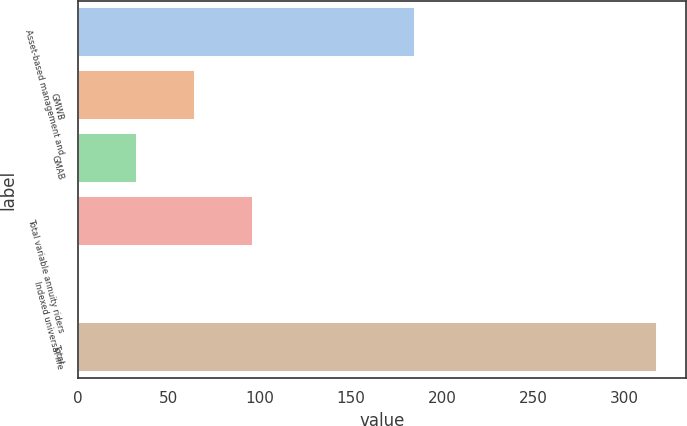<chart> <loc_0><loc_0><loc_500><loc_500><bar_chart><fcel>Asset-based management and<fcel>GMWB<fcel>GMAB<fcel>Total variable annuity riders<fcel>Indexed universal life<fcel>Total<nl><fcel>185<fcel>64.4<fcel>32.7<fcel>96.1<fcel>1<fcel>318<nl></chart> 